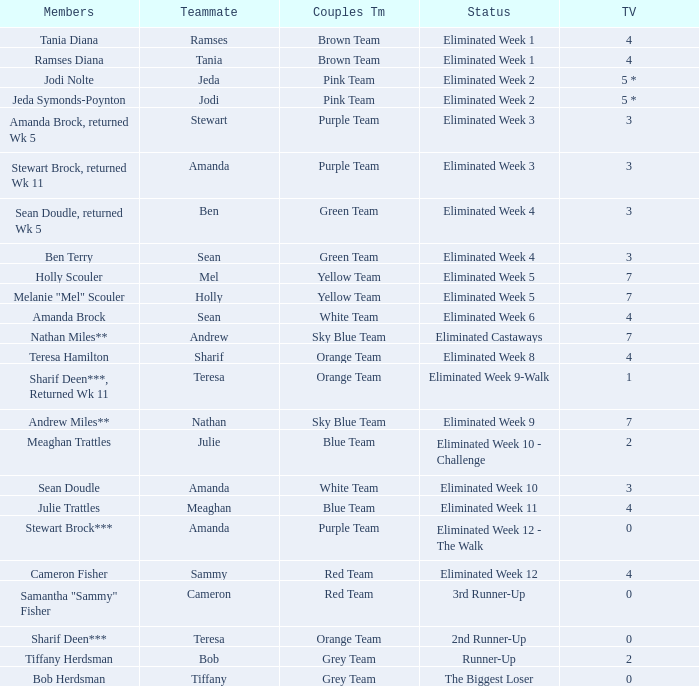What was Holly Scouler's total votes 7.0. 